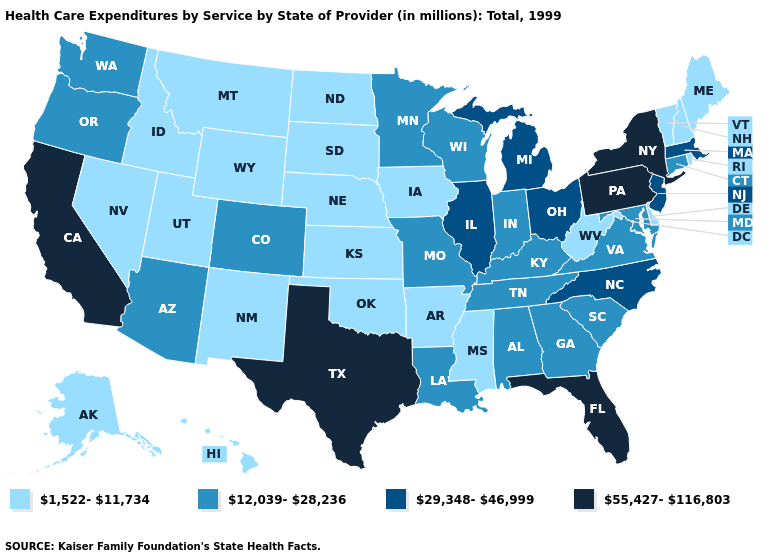What is the value of Maryland?
Keep it brief. 12,039-28,236. Which states hav the highest value in the MidWest?
Concise answer only. Illinois, Michigan, Ohio. What is the value of Colorado?
Keep it brief. 12,039-28,236. Does Kansas have the lowest value in the USA?
Answer briefly. Yes. What is the value of Virginia?
Short answer required. 12,039-28,236. What is the highest value in the USA?
Keep it brief. 55,427-116,803. Name the states that have a value in the range 55,427-116,803?
Keep it brief. California, Florida, New York, Pennsylvania, Texas. Name the states that have a value in the range 12,039-28,236?
Keep it brief. Alabama, Arizona, Colorado, Connecticut, Georgia, Indiana, Kentucky, Louisiana, Maryland, Minnesota, Missouri, Oregon, South Carolina, Tennessee, Virginia, Washington, Wisconsin. What is the highest value in the Northeast ?
Concise answer only. 55,427-116,803. Among the states that border Arizona , does Nevada have the highest value?
Give a very brief answer. No. Does South Dakota have the lowest value in the MidWest?
Quick response, please. Yes. What is the value of South Dakota?
Give a very brief answer. 1,522-11,734. What is the value of Indiana?
Be succinct. 12,039-28,236. Name the states that have a value in the range 29,348-46,999?
Give a very brief answer. Illinois, Massachusetts, Michigan, New Jersey, North Carolina, Ohio. Does Idaho have the highest value in the West?
Be succinct. No. 